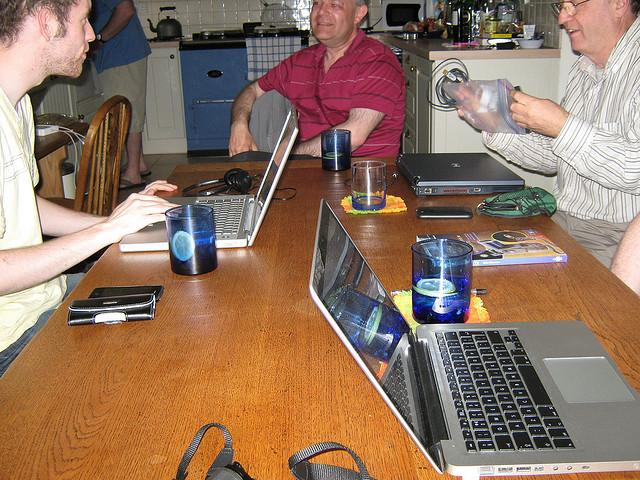Why is everyone at the table using laptops?

Choices:
A) they're hackers
B) they're repairmen
C) they're criminals
D) they're working they're working 